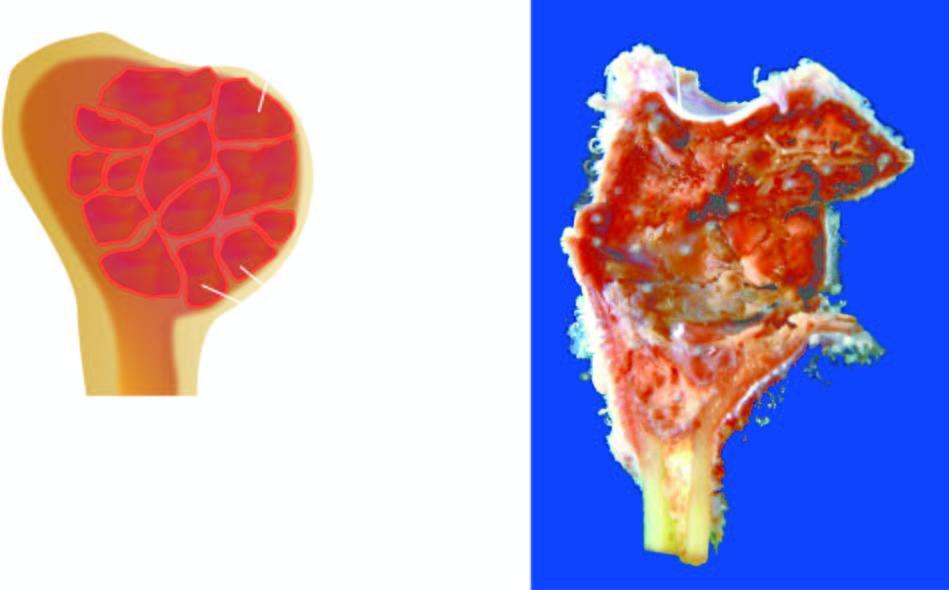s the anorectal margin expanded due to a cyst?
Answer the question using a single word or phrase. No 